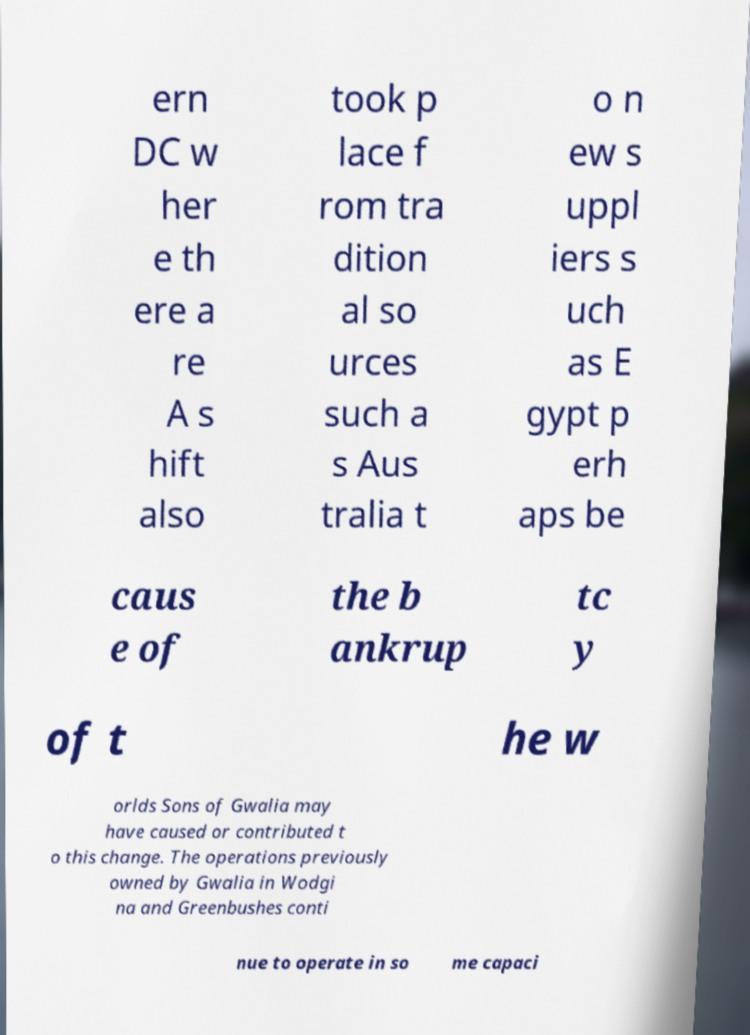There's text embedded in this image that I need extracted. Can you transcribe it verbatim? ern DC w her e th ere a re A s hift also took p lace f rom tra dition al so urces such a s Aus tralia t o n ew s uppl iers s uch as E gypt p erh aps be caus e of the b ankrup tc y of t he w orlds Sons of Gwalia may have caused or contributed t o this change. The operations previously owned by Gwalia in Wodgi na and Greenbushes conti nue to operate in so me capaci 